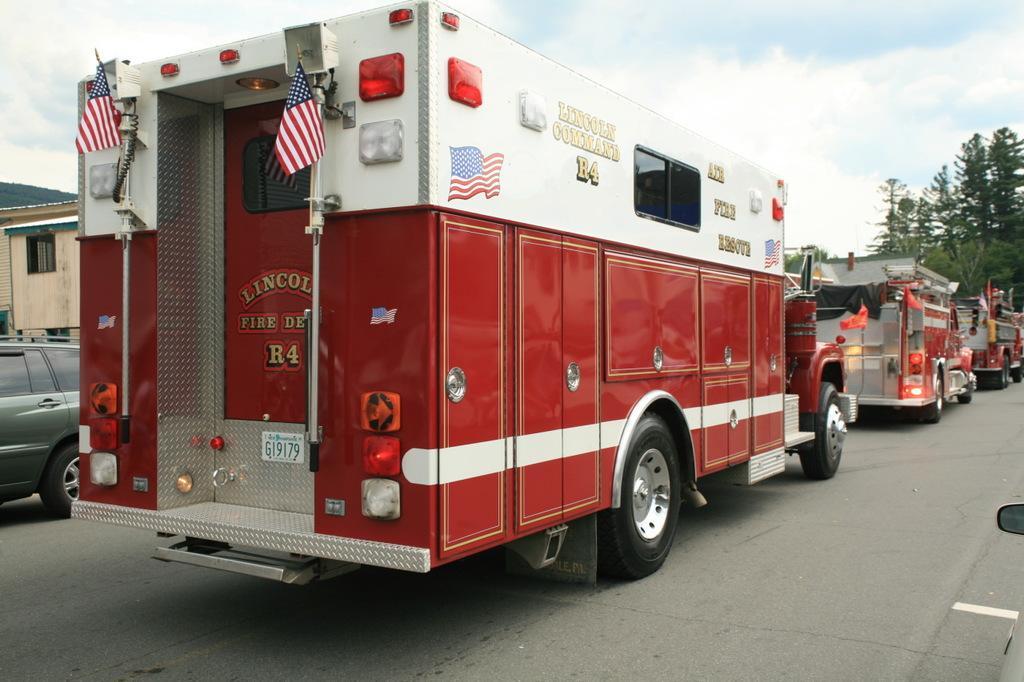Can you describe this image briefly? This image consists of three fire engine trucks in red color. At the bottom, there is a road. On the left, we can see a car and a building. On the right, there are trees. At the top, there are clouds in the sky. 